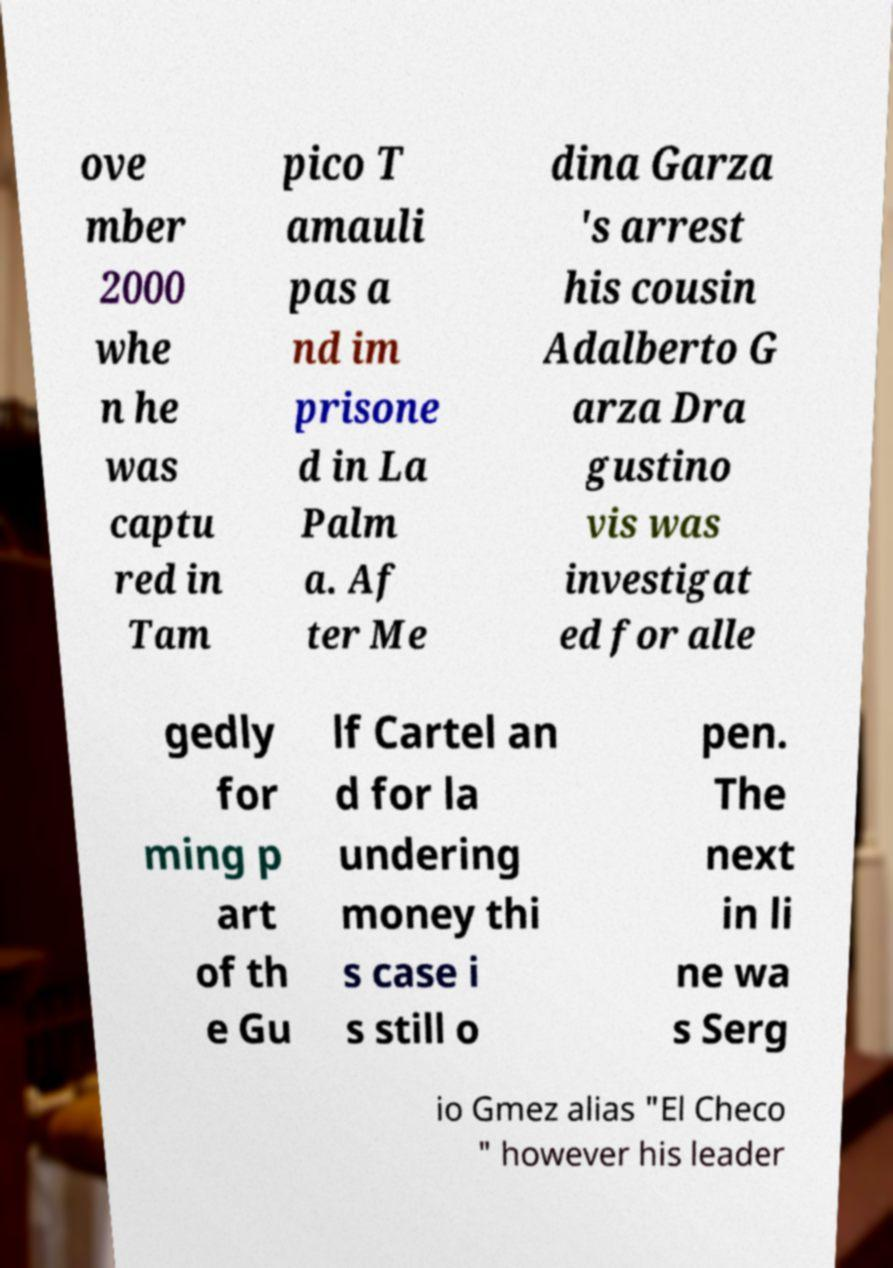Could you assist in decoding the text presented in this image and type it out clearly? ove mber 2000 whe n he was captu red in Tam pico T amauli pas a nd im prisone d in La Palm a. Af ter Me dina Garza 's arrest his cousin Adalberto G arza Dra gustino vis was investigat ed for alle gedly for ming p art of th e Gu lf Cartel an d for la undering money thi s case i s still o pen. The next in li ne wa s Serg io Gmez alias "El Checo " however his leader 